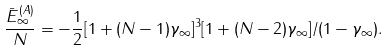Convert formula to latex. <formula><loc_0><loc_0><loc_500><loc_500>\frac { \bar { E } ^ { ( A ) } _ { \infty } } { N } = - \frac { 1 } { 2 } [ 1 + ( N - 1 ) \gamma _ { \infty } ] ^ { 3 } [ 1 + ( N - 2 ) \gamma _ { \infty } ] / ( 1 - \gamma _ { \infty } ) .</formula> 